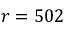Convert formula to latex. <formula><loc_0><loc_0><loc_500><loc_500>r = 5 0 2</formula> 